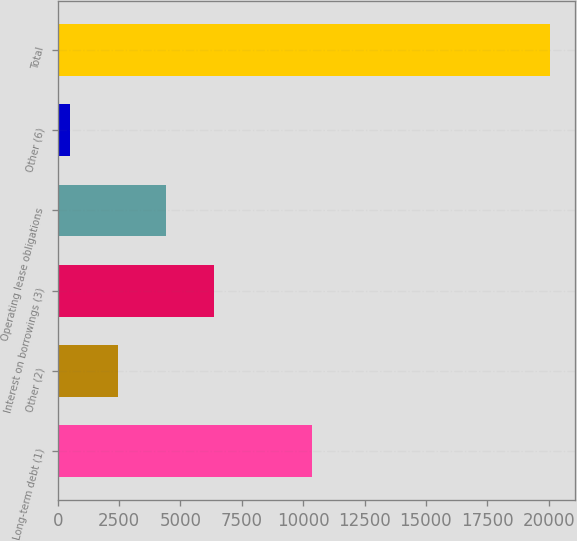Convert chart. <chart><loc_0><loc_0><loc_500><loc_500><bar_chart><fcel>Long-term debt (1)<fcel>Other (2)<fcel>Interest on borrowings (3)<fcel>Operating lease obligations<fcel>Other (6)<fcel>Total<nl><fcel>10373<fcel>2445.3<fcel>6359.9<fcel>4402.6<fcel>488<fcel>20061<nl></chart> 